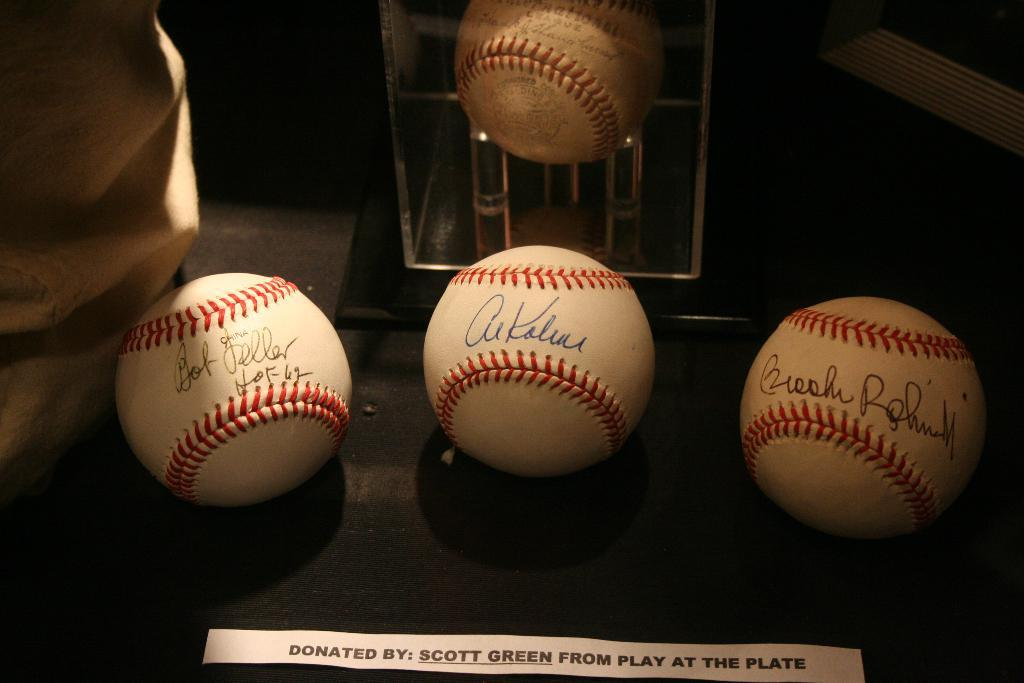Provide a one-sentence caption for the provided image. Baseballs on display donated by Scott Green from play at the plate. 